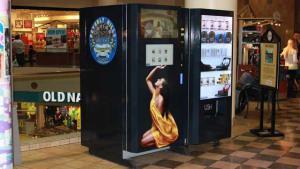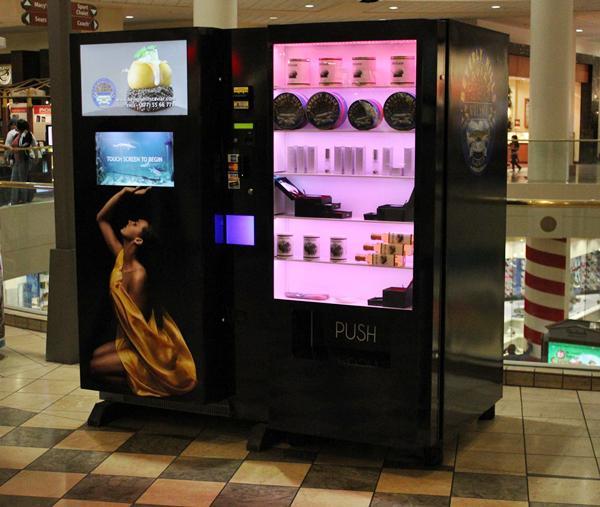The first image is the image on the left, the second image is the image on the right. For the images shown, is this caption "A person is standing directly in front of a vending machine decorated with a woman's image, in one picture." true? Answer yes or no. No. The first image is the image on the left, the second image is the image on the right. For the images displayed, is the sentence "One of the images has a male looking directly at the machine." factually correct? Answer yes or no. No. The first image is the image on the left, the second image is the image on the right. Examine the images to the left and right. Is the description "At least one image shows at least one person standing in front of a vending machine." accurate? Answer yes or no. No. The first image is the image on the left, the second image is the image on the right. Examine the images to the left and right. Is the description "The right image has at least one human facing towards the right in front of a vending machine." accurate? Answer yes or no. No. 